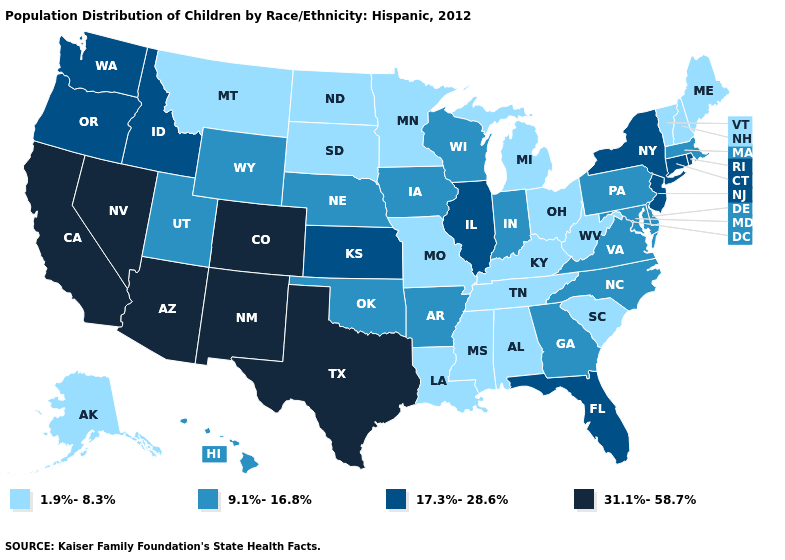Does California have the lowest value in the USA?
Answer briefly. No. Name the states that have a value in the range 1.9%-8.3%?
Concise answer only. Alabama, Alaska, Kentucky, Louisiana, Maine, Michigan, Minnesota, Mississippi, Missouri, Montana, New Hampshire, North Dakota, Ohio, South Carolina, South Dakota, Tennessee, Vermont, West Virginia. Does Maryland have the same value as West Virginia?
Quick response, please. No. Among the states that border Wisconsin , does Minnesota have the lowest value?
Keep it brief. Yes. What is the lowest value in the MidWest?
Short answer required. 1.9%-8.3%. Among the states that border Vermont , which have the lowest value?
Short answer required. New Hampshire. What is the highest value in states that border Tennessee?
Answer briefly. 9.1%-16.8%. Does Idaho have a higher value than California?
Give a very brief answer. No. What is the value of Nebraska?
Be succinct. 9.1%-16.8%. Name the states that have a value in the range 17.3%-28.6%?
Write a very short answer. Connecticut, Florida, Idaho, Illinois, Kansas, New Jersey, New York, Oregon, Rhode Island, Washington. Does Montana have the lowest value in the USA?
Answer briefly. Yes. What is the value of Minnesota?
Concise answer only. 1.9%-8.3%. Does North Carolina have the lowest value in the South?
Be succinct. No. Does North Carolina have a lower value than Wisconsin?
Write a very short answer. No. Does Mississippi have the lowest value in the South?
Concise answer only. Yes. 